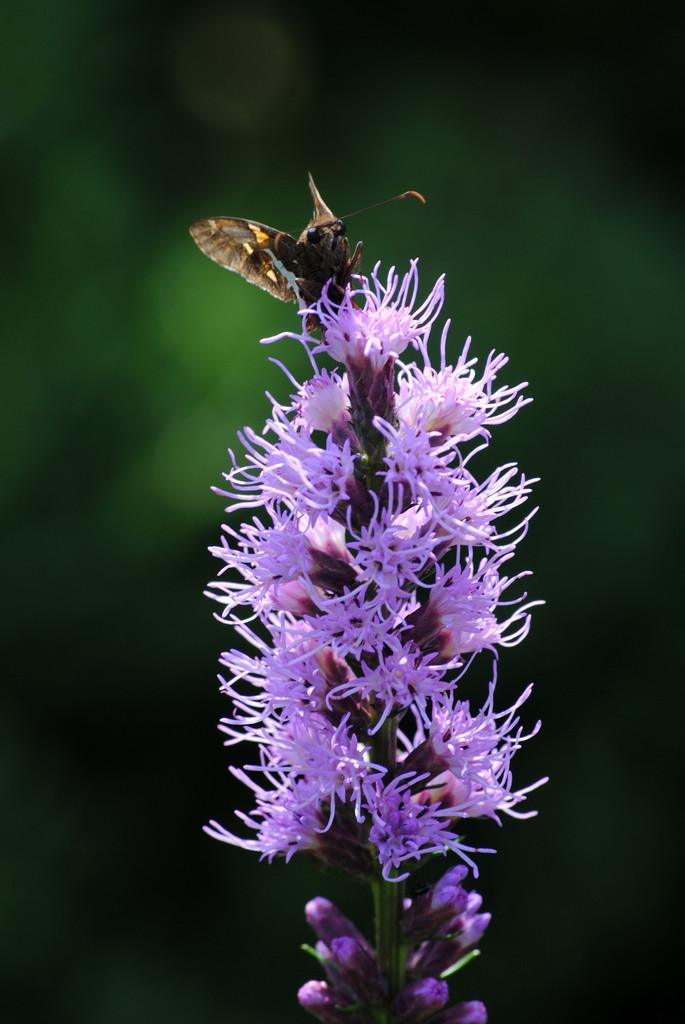What type of living organisms can be seen in the image? There are flowers and a butterfly in the image. Can you describe the interaction between the butterfly and the flowers? The butterfly is on a flower in the image. What color is the background of the image? The background of the image is green. What type of chicken can be seen in the image? There is no chicken present in the image; it features flowers and a butterfly. What type of iron object is visible in the image? There is no iron object present in the image. 